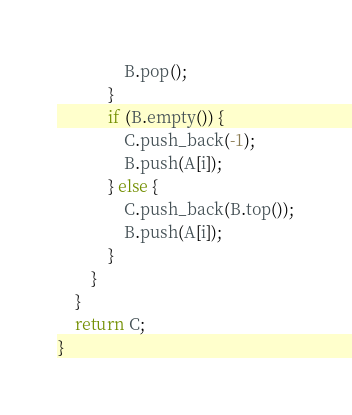<code> <loc_0><loc_0><loc_500><loc_500><_C++_>                B.pop();
            }
            if (B.empty()) {
                C.push_back(-1);
                B.push(A[i]);
            } else {
                C.push_back(B.top());
                B.push(A[i]);
            }
        }
    }
    return C;
}
</code> 